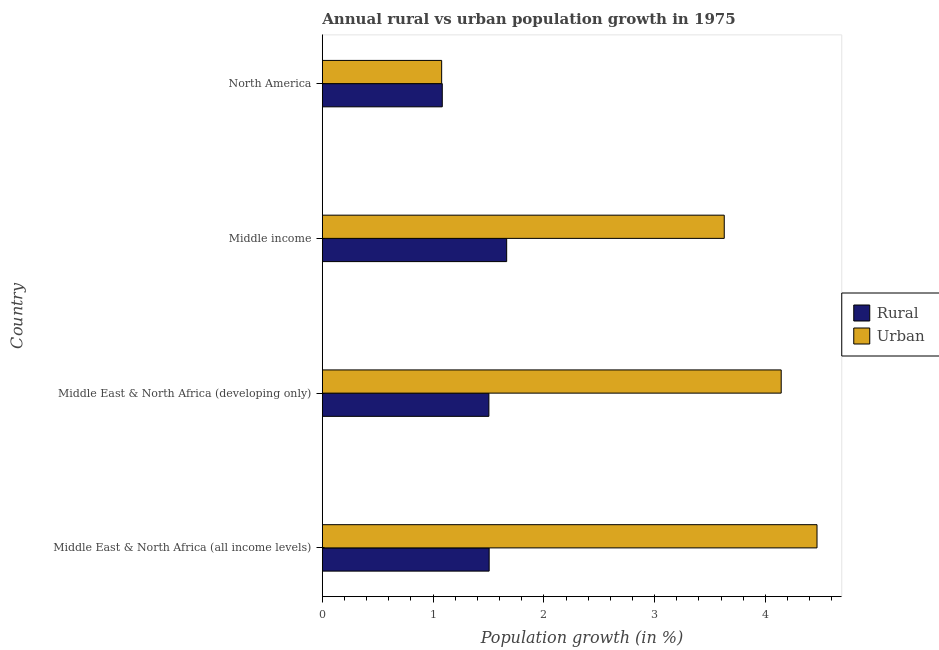How many different coloured bars are there?
Your response must be concise. 2. How many bars are there on the 2nd tick from the top?
Offer a very short reply. 2. How many bars are there on the 4th tick from the bottom?
Offer a terse response. 2. What is the label of the 3rd group of bars from the top?
Give a very brief answer. Middle East & North Africa (developing only). In how many cases, is the number of bars for a given country not equal to the number of legend labels?
Make the answer very short. 0. What is the urban population growth in North America?
Provide a short and direct response. 1.08. Across all countries, what is the maximum rural population growth?
Your response must be concise. 1.66. Across all countries, what is the minimum urban population growth?
Your response must be concise. 1.08. In which country was the rural population growth maximum?
Offer a terse response. Middle income. What is the total rural population growth in the graph?
Ensure brevity in your answer.  5.76. What is the difference between the urban population growth in Middle income and that in North America?
Your response must be concise. 2.55. What is the difference between the urban population growth in Middle income and the rural population growth in Middle East & North Africa (developing only)?
Keep it short and to the point. 2.12. What is the average urban population growth per country?
Offer a very short reply. 3.33. What is the difference between the rural population growth and urban population growth in North America?
Give a very brief answer. 0.01. In how many countries, is the urban population growth greater than 3.8 %?
Your answer should be very brief. 2. What is the ratio of the rural population growth in Middle East & North Africa (developing only) to that in North America?
Provide a succinct answer. 1.39. What is the difference between the highest and the second highest urban population growth?
Keep it short and to the point. 0.32. What is the difference between the highest and the lowest rural population growth?
Provide a succinct answer. 0.58. What does the 2nd bar from the top in Middle East & North Africa (developing only) represents?
Make the answer very short. Rural. What does the 1st bar from the bottom in Middle East & North Africa (developing only) represents?
Your response must be concise. Rural. How many bars are there?
Offer a terse response. 8. Are all the bars in the graph horizontal?
Give a very brief answer. Yes. What is the difference between two consecutive major ticks on the X-axis?
Make the answer very short. 1. Does the graph contain grids?
Give a very brief answer. No. Where does the legend appear in the graph?
Your answer should be compact. Center right. What is the title of the graph?
Keep it short and to the point. Annual rural vs urban population growth in 1975. Does "Urban" appear as one of the legend labels in the graph?
Provide a succinct answer. No. What is the label or title of the X-axis?
Make the answer very short. Population growth (in %). What is the label or title of the Y-axis?
Ensure brevity in your answer.  Country. What is the Population growth (in %) in Rural in Middle East & North Africa (all income levels)?
Give a very brief answer. 1.51. What is the Population growth (in %) in Urban  in Middle East & North Africa (all income levels)?
Your answer should be very brief. 4.47. What is the Population growth (in %) in Rural in Middle East & North Africa (developing only)?
Your response must be concise. 1.5. What is the Population growth (in %) of Urban  in Middle East & North Africa (developing only)?
Ensure brevity in your answer.  4.14. What is the Population growth (in %) of Rural in Middle income?
Your answer should be compact. 1.66. What is the Population growth (in %) of Urban  in Middle income?
Your response must be concise. 3.63. What is the Population growth (in %) of Rural in North America?
Make the answer very short. 1.08. What is the Population growth (in %) in Urban  in North America?
Your answer should be very brief. 1.08. Across all countries, what is the maximum Population growth (in %) in Rural?
Your response must be concise. 1.66. Across all countries, what is the maximum Population growth (in %) of Urban ?
Make the answer very short. 4.47. Across all countries, what is the minimum Population growth (in %) in Rural?
Make the answer very short. 1.08. Across all countries, what is the minimum Population growth (in %) in Urban ?
Make the answer very short. 1.08. What is the total Population growth (in %) of Rural in the graph?
Ensure brevity in your answer.  5.76. What is the total Population growth (in %) in Urban  in the graph?
Your answer should be very brief. 13.32. What is the difference between the Population growth (in %) in Rural in Middle East & North Africa (all income levels) and that in Middle East & North Africa (developing only)?
Make the answer very short. 0. What is the difference between the Population growth (in %) of Urban  in Middle East & North Africa (all income levels) and that in Middle East & North Africa (developing only)?
Give a very brief answer. 0.32. What is the difference between the Population growth (in %) in Rural in Middle East & North Africa (all income levels) and that in Middle income?
Give a very brief answer. -0.16. What is the difference between the Population growth (in %) of Urban  in Middle East & North Africa (all income levels) and that in Middle income?
Keep it short and to the point. 0.84. What is the difference between the Population growth (in %) in Rural in Middle East & North Africa (all income levels) and that in North America?
Provide a succinct answer. 0.42. What is the difference between the Population growth (in %) in Urban  in Middle East & North Africa (all income levels) and that in North America?
Provide a short and direct response. 3.39. What is the difference between the Population growth (in %) in Rural in Middle East & North Africa (developing only) and that in Middle income?
Give a very brief answer. -0.16. What is the difference between the Population growth (in %) in Urban  in Middle East & North Africa (developing only) and that in Middle income?
Keep it short and to the point. 0.51. What is the difference between the Population growth (in %) of Rural in Middle East & North Africa (developing only) and that in North America?
Your answer should be very brief. 0.42. What is the difference between the Population growth (in %) of Urban  in Middle East & North Africa (developing only) and that in North America?
Keep it short and to the point. 3.07. What is the difference between the Population growth (in %) in Rural in Middle income and that in North America?
Offer a terse response. 0.58. What is the difference between the Population growth (in %) of Urban  in Middle income and that in North America?
Provide a short and direct response. 2.55. What is the difference between the Population growth (in %) in Rural in Middle East & North Africa (all income levels) and the Population growth (in %) in Urban  in Middle East & North Africa (developing only)?
Ensure brevity in your answer.  -2.64. What is the difference between the Population growth (in %) in Rural in Middle East & North Africa (all income levels) and the Population growth (in %) in Urban  in Middle income?
Give a very brief answer. -2.12. What is the difference between the Population growth (in %) in Rural in Middle East & North Africa (all income levels) and the Population growth (in %) in Urban  in North America?
Provide a short and direct response. 0.43. What is the difference between the Population growth (in %) of Rural in Middle East & North Africa (developing only) and the Population growth (in %) of Urban  in Middle income?
Keep it short and to the point. -2.12. What is the difference between the Population growth (in %) of Rural in Middle East & North Africa (developing only) and the Population growth (in %) of Urban  in North America?
Offer a terse response. 0.43. What is the difference between the Population growth (in %) of Rural in Middle income and the Population growth (in %) of Urban  in North America?
Your answer should be very brief. 0.59. What is the average Population growth (in %) in Rural per country?
Provide a succinct answer. 1.44. What is the average Population growth (in %) in Urban  per country?
Ensure brevity in your answer.  3.33. What is the difference between the Population growth (in %) in Rural and Population growth (in %) in Urban  in Middle East & North Africa (all income levels)?
Make the answer very short. -2.96. What is the difference between the Population growth (in %) of Rural and Population growth (in %) of Urban  in Middle East & North Africa (developing only)?
Provide a short and direct response. -2.64. What is the difference between the Population growth (in %) of Rural and Population growth (in %) of Urban  in Middle income?
Your answer should be very brief. -1.96. What is the difference between the Population growth (in %) of Rural and Population growth (in %) of Urban  in North America?
Offer a very short reply. 0.01. What is the ratio of the Population growth (in %) in Rural in Middle East & North Africa (all income levels) to that in Middle East & North Africa (developing only)?
Give a very brief answer. 1. What is the ratio of the Population growth (in %) in Urban  in Middle East & North Africa (all income levels) to that in Middle East & North Africa (developing only)?
Your answer should be very brief. 1.08. What is the ratio of the Population growth (in %) in Rural in Middle East & North Africa (all income levels) to that in Middle income?
Provide a succinct answer. 0.91. What is the ratio of the Population growth (in %) in Urban  in Middle East & North Africa (all income levels) to that in Middle income?
Your answer should be compact. 1.23. What is the ratio of the Population growth (in %) of Rural in Middle East & North Africa (all income levels) to that in North America?
Your response must be concise. 1.39. What is the ratio of the Population growth (in %) in Urban  in Middle East & North Africa (all income levels) to that in North America?
Make the answer very short. 4.15. What is the ratio of the Population growth (in %) of Rural in Middle East & North Africa (developing only) to that in Middle income?
Provide a succinct answer. 0.9. What is the ratio of the Population growth (in %) of Urban  in Middle East & North Africa (developing only) to that in Middle income?
Offer a very short reply. 1.14. What is the ratio of the Population growth (in %) in Rural in Middle East & North Africa (developing only) to that in North America?
Keep it short and to the point. 1.39. What is the ratio of the Population growth (in %) of Urban  in Middle East & North Africa (developing only) to that in North America?
Your answer should be compact. 3.85. What is the ratio of the Population growth (in %) of Rural in Middle income to that in North America?
Your answer should be compact. 1.54. What is the ratio of the Population growth (in %) in Urban  in Middle income to that in North America?
Your answer should be very brief. 3.37. What is the difference between the highest and the second highest Population growth (in %) of Rural?
Give a very brief answer. 0.16. What is the difference between the highest and the second highest Population growth (in %) in Urban ?
Offer a very short reply. 0.32. What is the difference between the highest and the lowest Population growth (in %) in Rural?
Your answer should be very brief. 0.58. What is the difference between the highest and the lowest Population growth (in %) of Urban ?
Your answer should be very brief. 3.39. 